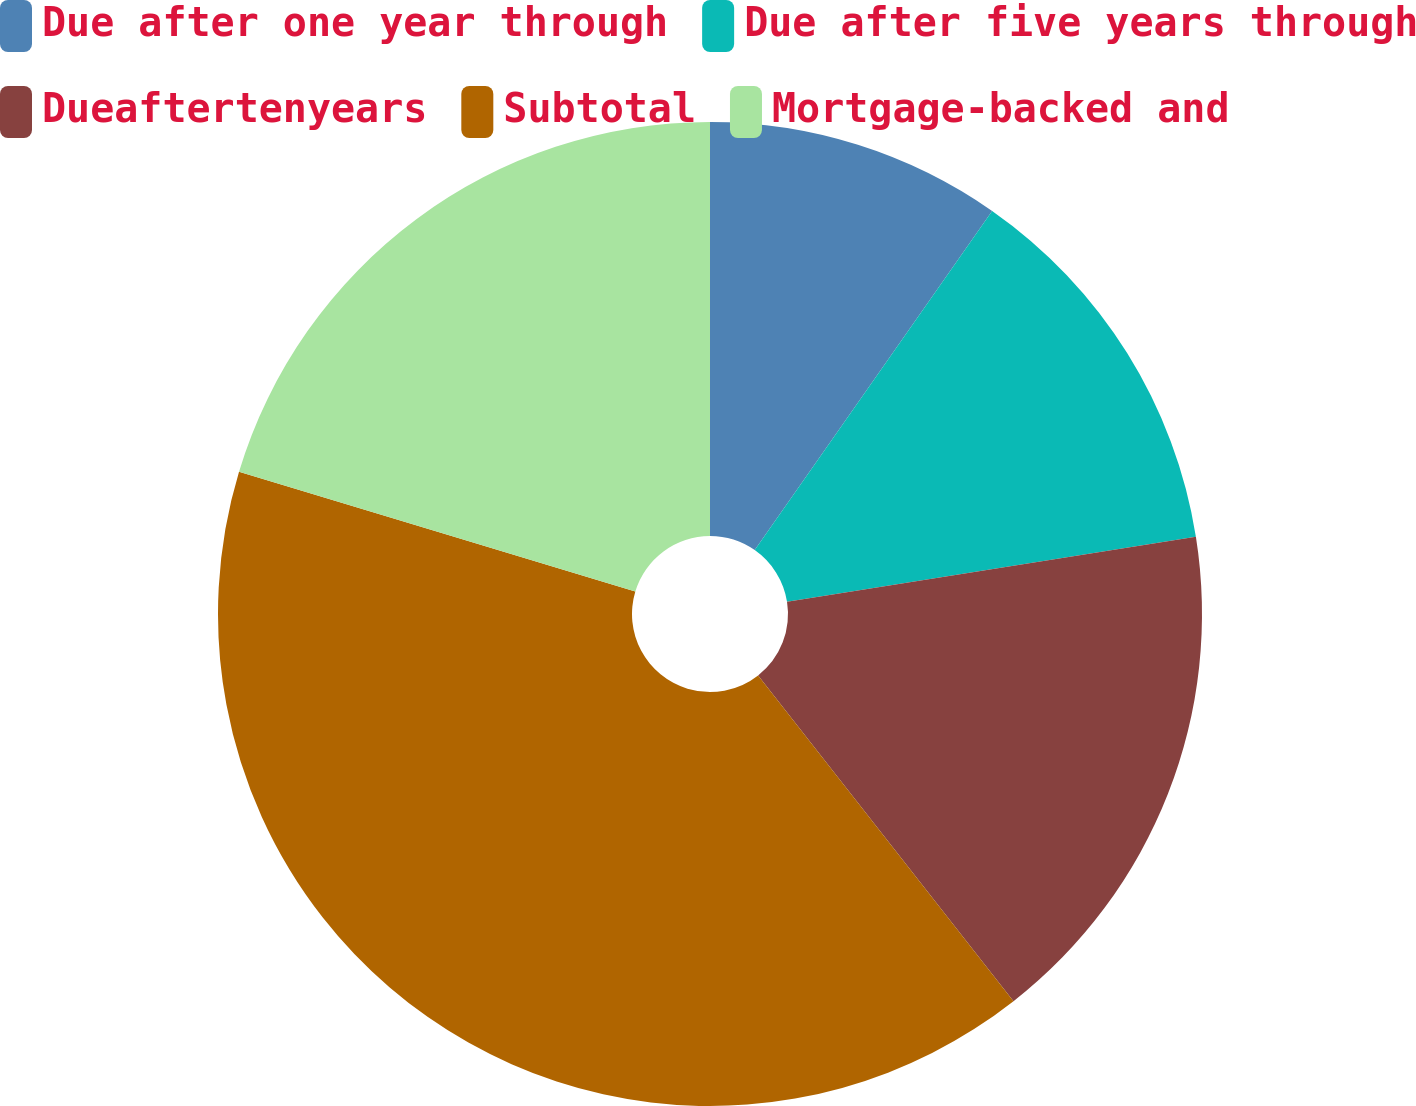<chart> <loc_0><loc_0><loc_500><loc_500><pie_chart><fcel>Due after one year through<fcel>Due after five years through<fcel>Dueaftertenyears<fcel>Subtotal<fcel>Mortgage-backed and<nl><fcel>9.72%<fcel>12.77%<fcel>16.93%<fcel>40.25%<fcel>20.33%<nl></chart> 